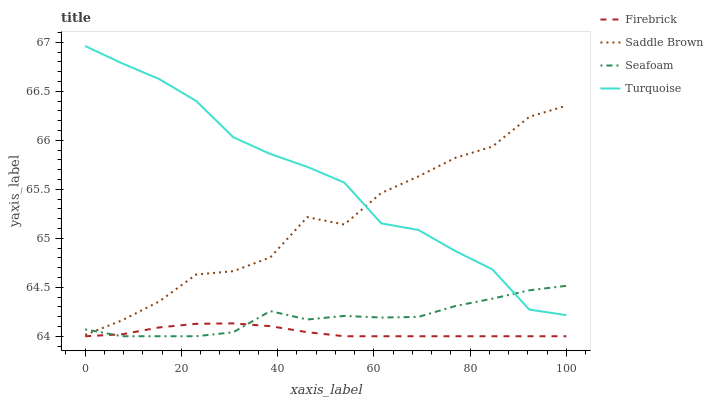Does Saddle Brown have the minimum area under the curve?
Answer yes or no. No. Does Saddle Brown have the maximum area under the curve?
Answer yes or no. No. Is Turquoise the smoothest?
Answer yes or no. No. Is Turquoise the roughest?
Answer yes or no. No. Does Saddle Brown have the lowest value?
Answer yes or no. No. Does Saddle Brown have the highest value?
Answer yes or no. No. Is Firebrick less than Saddle Brown?
Answer yes or no. Yes. Is Saddle Brown greater than Firebrick?
Answer yes or no. Yes. Does Firebrick intersect Saddle Brown?
Answer yes or no. No. 